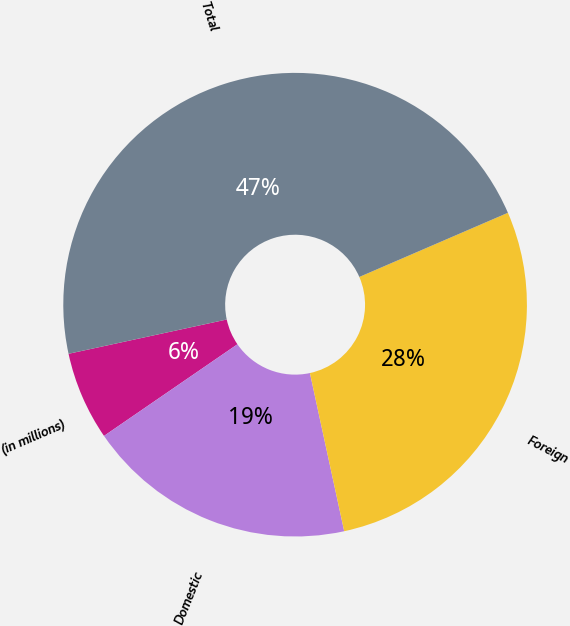Convert chart to OTSL. <chart><loc_0><loc_0><loc_500><loc_500><pie_chart><fcel>(in millions)<fcel>Domestic<fcel>Foreign<fcel>Total<nl><fcel>6.18%<fcel>18.82%<fcel>28.09%<fcel>46.91%<nl></chart> 